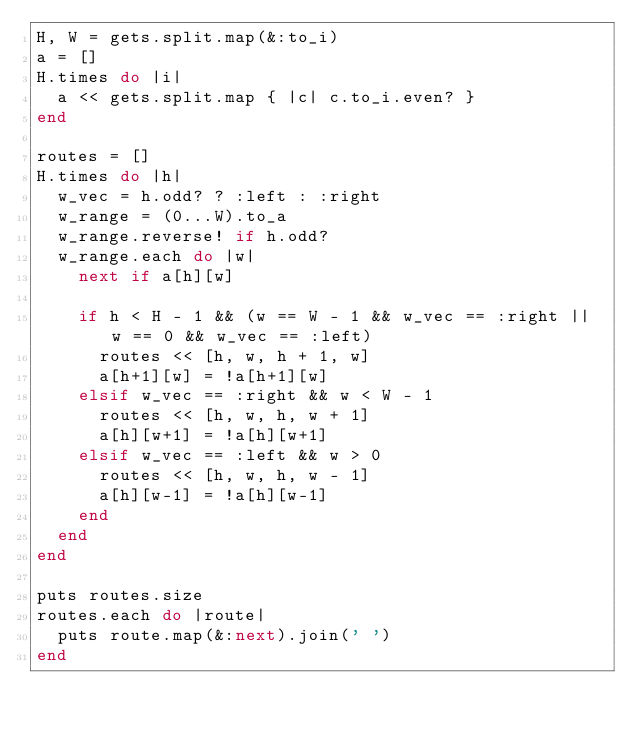Convert code to text. <code><loc_0><loc_0><loc_500><loc_500><_Ruby_>H, W = gets.split.map(&:to_i)
a = []
H.times do |i|
  a << gets.split.map { |c| c.to_i.even? }
end

routes = []
H.times do |h|
  w_vec = h.odd? ? :left : :right
  w_range = (0...W).to_a
  w_range.reverse! if h.odd?
  w_range.each do |w|
    next if a[h][w]

    if h < H - 1 && (w == W - 1 && w_vec == :right || w == 0 && w_vec == :left)
      routes << [h, w, h + 1, w]
      a[h+1][w] = !a[h+1][w]
    elsif w_vec == :right && w < W - 1
      routes << [h, w, h, w + 1]
      a[h][w+1] = !a[h][w+1]
    elsif w_vec == :left && w > 0
      routes << [h, w, h, w - 1]
      a[h][w-1] = !a[h][w-1]
    end
  end
end

puts routes.size
routes.each do |route|
  puts route.map(&:next).join(' ')
end</code> 